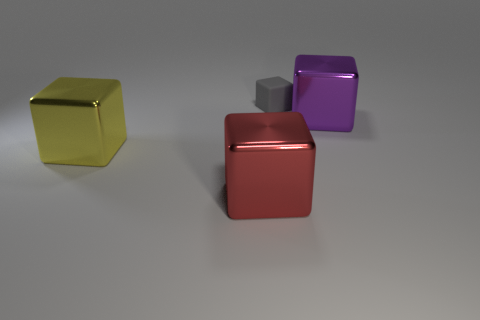There is a thing that is behind the big shiny object to the right of the cube that is behind the big purple thing; what is its material?
Ensure brevity in your answer.  Rubber. What is the small gray object made of?
Your answer should be compact. Rubber. There is a gray object that is the same shape as the large yellow metal thing; what size is it?
Keep it short and to the point. Small. How many other things are made of the same material as the gray cube?
Give a very brief answer. 0. Is the number of small gray matte objects on the right side of the tiny rubber object the same as the number of tiny cyan spheres?
Your answer should be compact. Yes. There is a metal thing in front of the yellow shiny object; is its size the same as the big purple cube?
Your answer should be compact. Yes. There is a red block; how many big cubes are left of it?
Your response must be concise. 1. What is the thing that is behind the red shiny cube and left of the small gray cube made of?
Ensure brevity in your answer.  Metal. What number of large things are either gray matte cubes or metal blocks?
Make the answer very short. 3. What is the size of the gray block?
Provide a succinct answer. Small. 